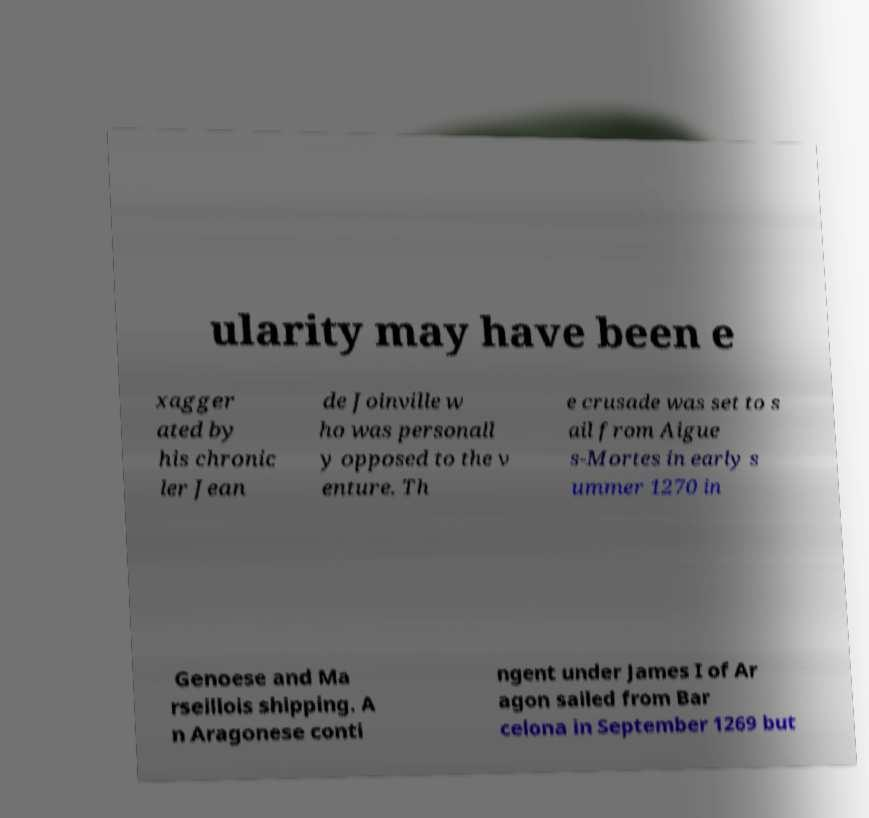For documentation purposes, I need the text within this image transcribed. Could you provide that? ularity may have been e xagger ated by his chronic ler Jean de Joinville w ho was personall y opposed to the v enture. Th e crusade was set to s ail from Aigue s-Mortes in early s ummer 1270 in Genoese and Ma rseillois shipping. A n Aragonese conti ngent under James I of Ar agon sailed from Bar celona in September 1269 but 